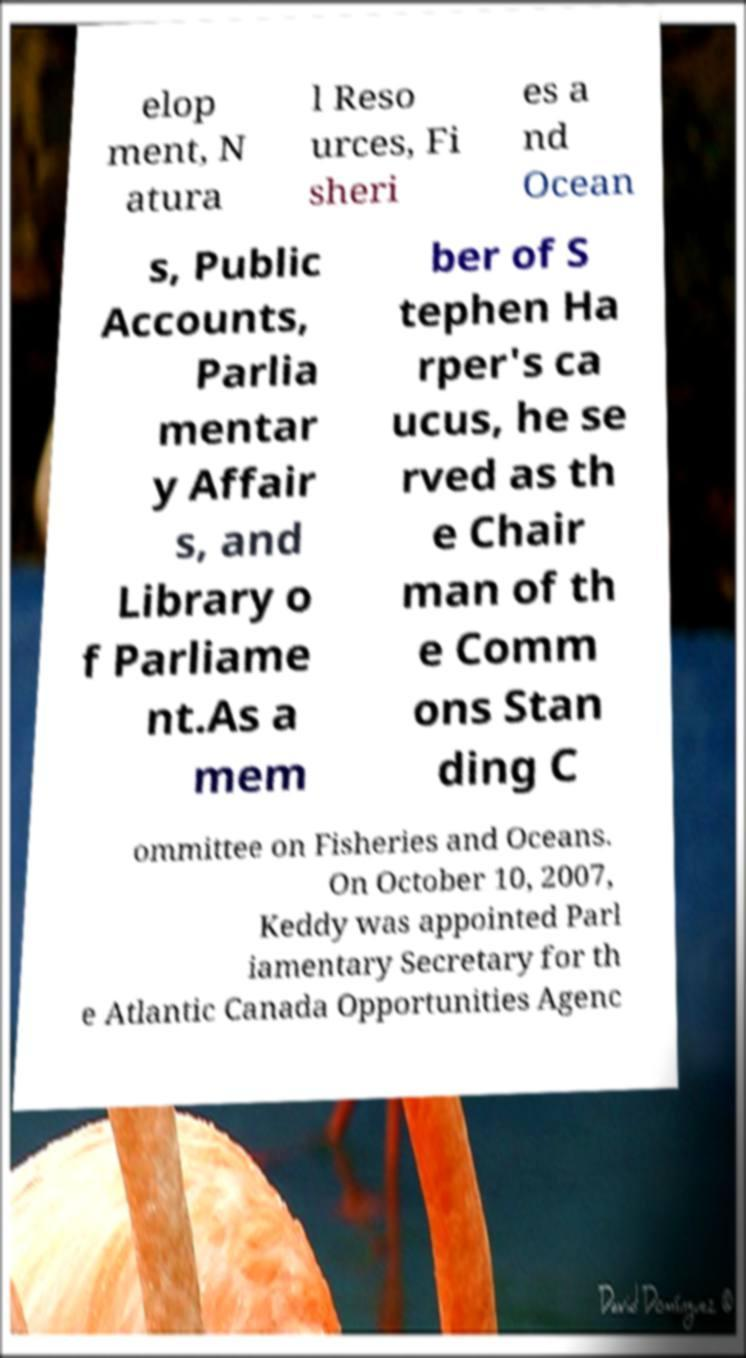Could you assist in decoding the text presented in this image and type it out clearly? elop ment, N atura l Reso urces, Fi sheri es a nd Ocean s, Public Accounts, Parlia mentar y Affair s, and Library o f Parliame nt.As a mem ber of S tephen Ha rper's ca ucus, he se rved as th e Chair man of th e Comm ons Stan ding C ommittee on Fisheries and Oceans. On October 10, 2007, Keddy was appointed Parl iamentary Secretary for th e Atlantic Canada Opportunities Agenc 